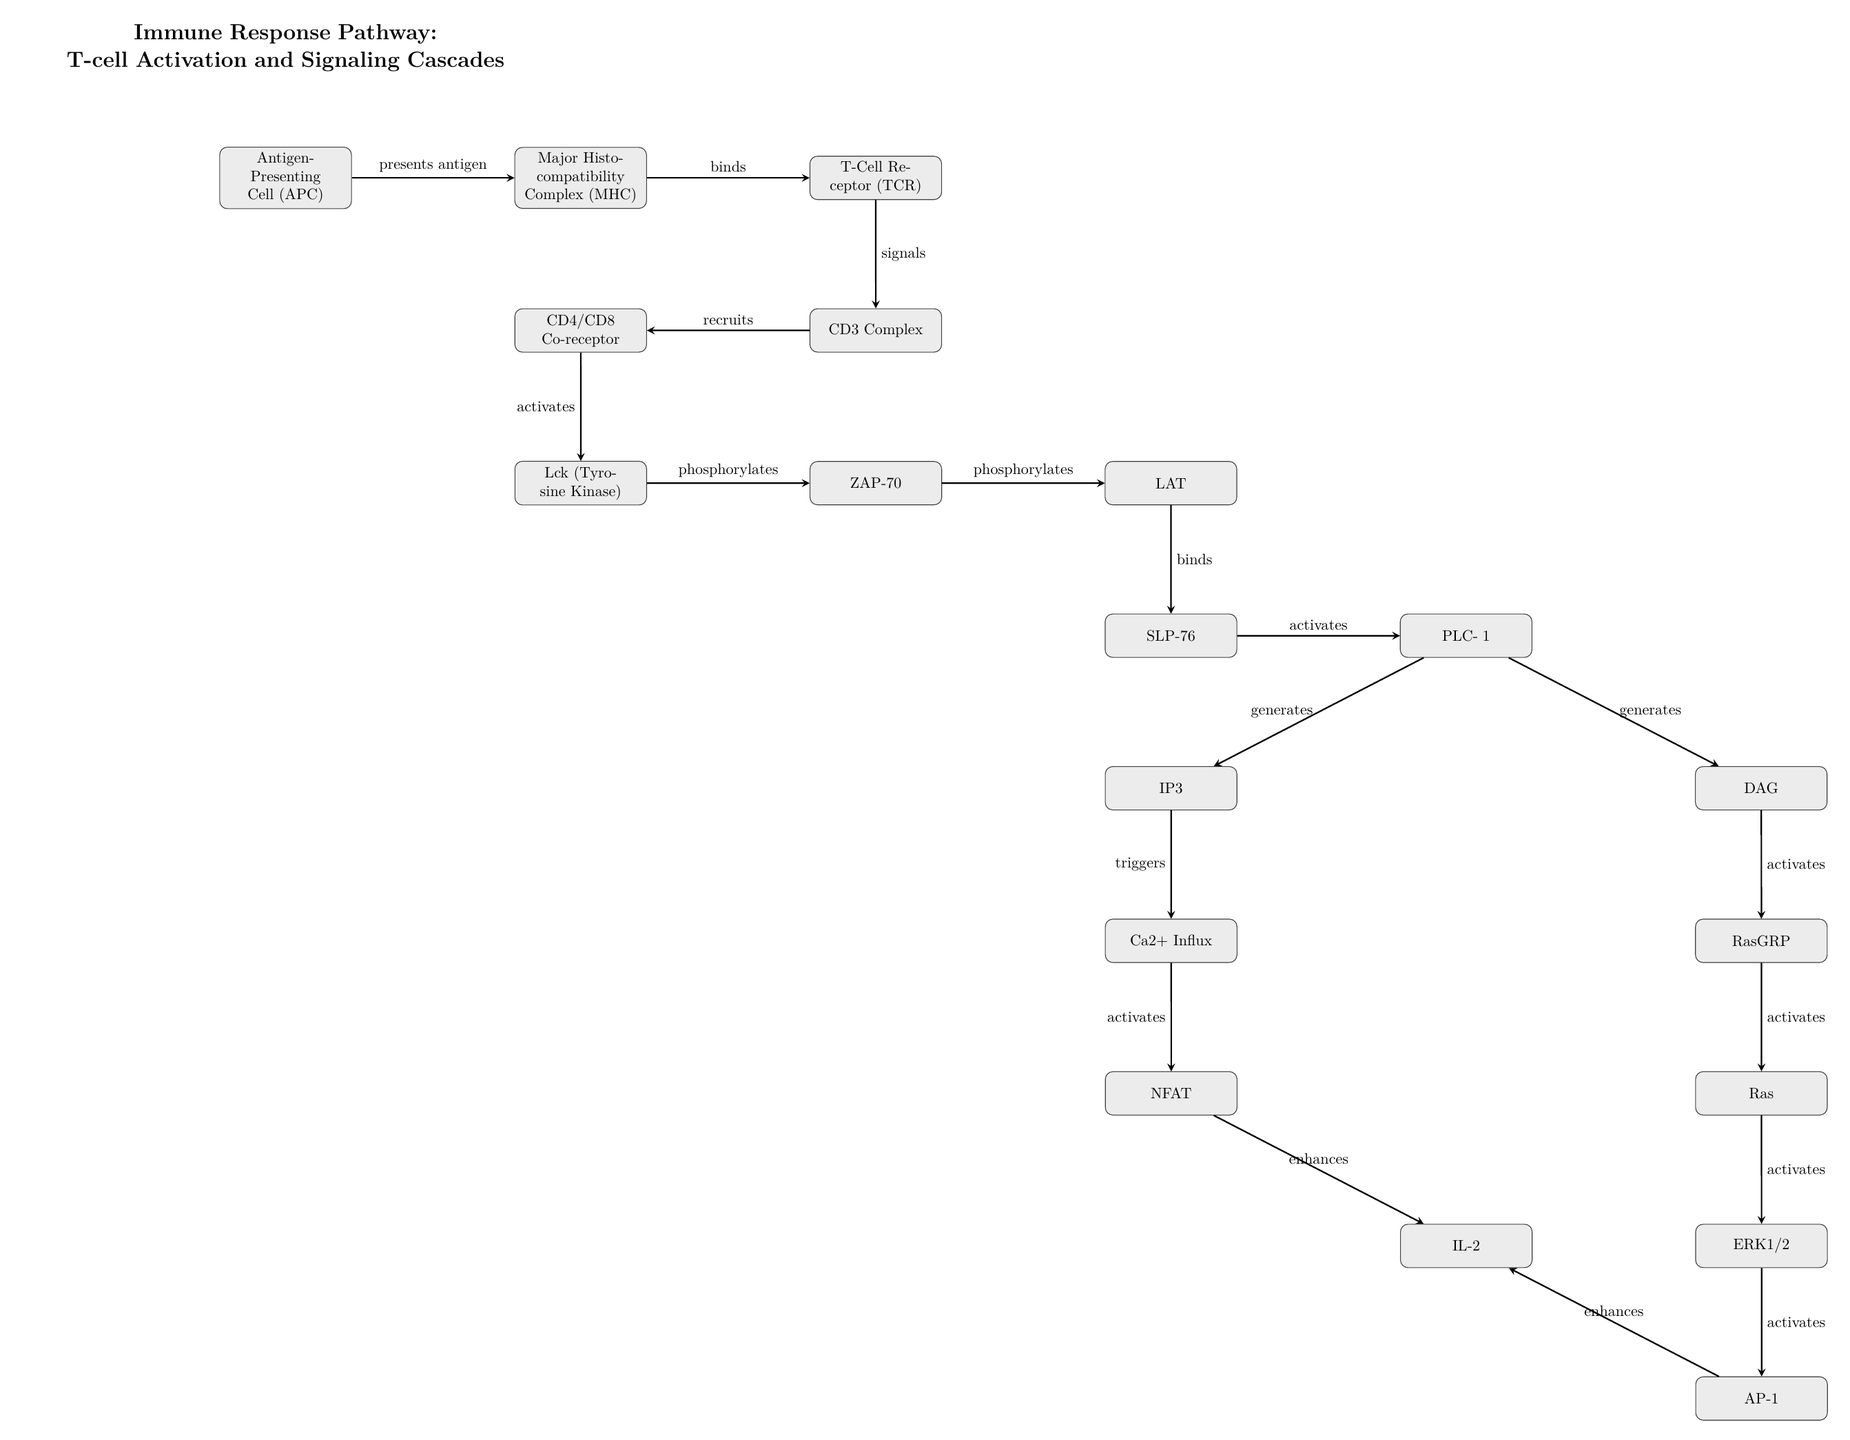What is the first node in the diagram? The first node is labeled "Antigen-Presenting Cell (APC)." It is positioned at the upper left corner of the diagram, indicating it initiates the immune response pathway.
Answer: Antigen-Presenting Cell (APC) How many main processes are shown in the diagram? The diagram contains a total of 19 nodes that represent different processes or components involved in T-cell activation and signaling cascades. Counting each distinct labeled process provides the answer.
Answer: 19 What does the Major Histocompatibility Complex (MHC) do? MHC binds to the T-Cell Receptor (TCR), as indicated by the arrow connecting the two nodes. This interaction is essential for T-cell activation as MHC presents antigens to T-cells.
Answer: Binds Which components are responsible for generating IP3 and DAG? PLC-γ1 is responsible for generating both IP3 and DAG as indicated by the arrows leading from PLC-γ1 to both IP3 and DAG nodes, indicating its role in the signaling cascade.
Answer: PLC-γ1 What activates Ca2+ influx? Ca2+ influx is triggered by IP3, as shown by the arrow leading from the IP3 node down to the Ca2+ influx node, indicating that IP3 influences the rise in intracellular calcium levels essential for T-cell activation.
Answer: IP3 Which two nodes enhance IL-2? IL-2 is enhanced by both NFAT and AP-1 as shown by the arrows pointing from the NFAT node and the AP-1 node to the IL-2 node, indicating that both factors contribute positively to IL-2 production.
Answer: NFAT, AP-1 What role does Lck play in the pathway? Lck phosphorylates ZAP-70, as indicated by the arrow leading from the Lck node to the ZAP-70 node, which indicates that Lck is an important tyrosine kinase involved in T-cell receptor signaling.
Answer: Phosphorylates Which process directly recruits the CD4/CD8 Co-receptor? The process that directly recruits the CD4/CD8 Co-receptor is signaling from the CD3 Complex, as shown by the arrow that points from the CD3 Complex to the CD4/CD8 Co-receptor node.
Answer: Signals Which component is last in the cascade leading to IL-2? The last component in the cascade leading to IL-2 is AP-1, which is positioned right before IL-2 in the diagram showing that AP-1 is essential for enhancing IL-2 production.
Answer: AP-1 